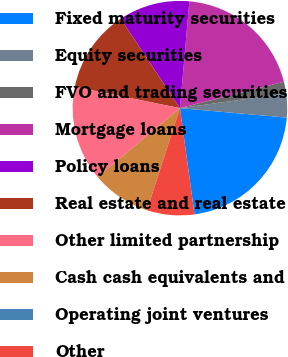Convert chart. <chart><loc_0><loc_0><loc_500><loc_500><pie_chart><fcel>Fixed maturity securities<fcel>Equity securities<fcel>FVO and trading securities<fcel>Mortgage loans<fcel>Policy loans<fcel>Real estate and real estate<fcel>Other limited partnership<fcel>Cash cash equivalents and<fcel>Operating joint ventures<fcel>Other<nl><fcel>21.42%<fcel>3.58%<fcel>1.79%<fcel>19.64%<fcel>10.71%<fcel>12.5%<fcel>14.28%<fcel>8.93%<fcel>0.01%<fcel>7.15%<nl></chart> 